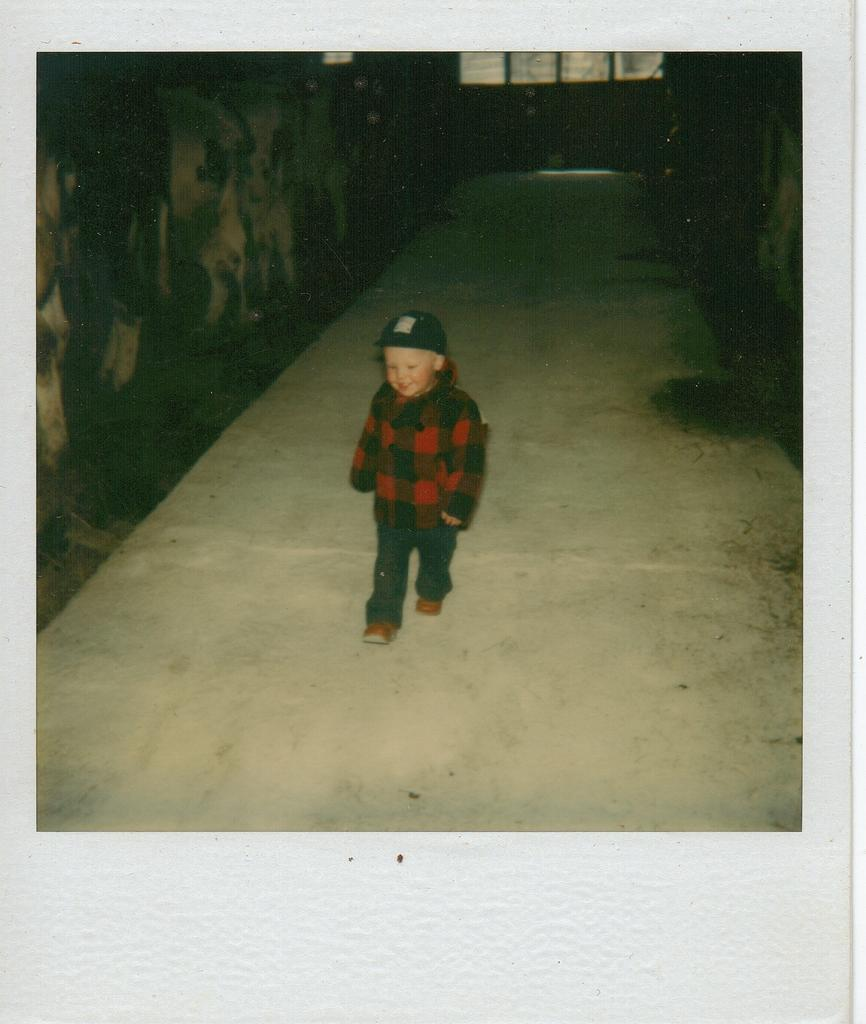Who is the main subject in the image? There is a boy in the image. What is the boy doing in the image? The boy is walking. What is the boy wearing on his head? The boy is wearing a cap. What type of structure can be seen in the image? There are walls visible in the image. What type of juice is the boy holding in the image? There is no juice present in the image; the boy is not holding any. 